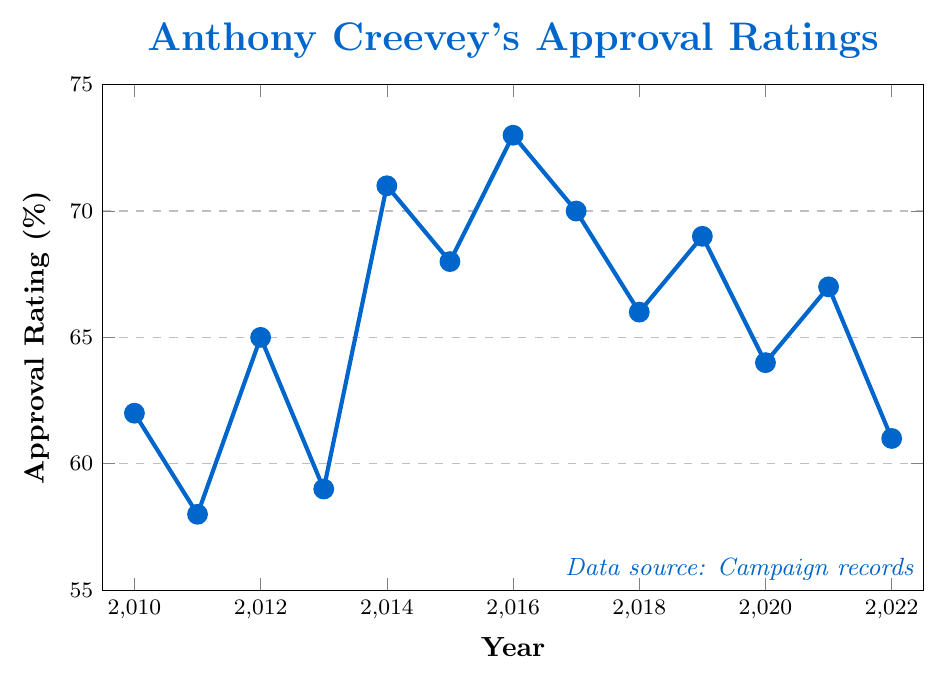What was Anthony Creevey's highest approval rating, and in which year did it occur? Look at the peak point of the line on the figure. The highest approval rating is shown as the tallest marker on the graph. It occurs at 2016 with a value of 73%.
Answer: 73%, 2016 Which year showed the greatest increase in approval rating from the previous year? Identify the year where the line's increase between two adjacent points is the steepest. The greatest increase goes from 2013 at 59% to 2014 at 71%, an increase of 12 percentage points.
Answer: 2014 In how many different years did Anthony Creevey's approval rating stay above 65%? Identify and count the years where the approval rating points are above 65%. These years are 2012 (65%), 2014 (71%), 2015 (68%), 2016 (73%), 2017 (70%), 2019 (69%), and 2021 (67%). There are 7 such years.
Answer: 7 What is the average approval rating for Anthony Creevey from 2010 to 2022? Sum up all the approval ratings between 2010 and 2022 and divide by the number of years. (62 + 58 + 65 + 59 + 71 + 68 + 73 + 70 + 66 + 69 + 64 + 67 + 61) / 13 = 65.31
Answer: 65.31 Compare the approval rating in 2010 with that in 2022. How did it change? Examine the two values for 2010 and 2022. In 2010, it was 62%, and in 2022, it was 61%, showing a decrease of 1 percentage point.
Answer: Decreased by 1 percentage point What was the lowest approval rating and when did it occur? Find the lowest point on the line chart. This occurs at 2011 with the lowest approval rating of 58%.
Answer: 58%, 2011 Identify the year where the approval rating first surpassed 70%. Look for the point where the rating first crosses the 70% line. The first occurrence is in 2014 with a 71% rating.
Answer: 2014 What is the difference in approval ratings between the highest and lowest years? Subtract the lowest approval rating from the highest. The highest is 73% (2016), and the lowest is 58% (2011), so 73 - 58 = 15 percentage points.
Answer: 15 From which year to which year did the approval rating steadily increase without a drop? Look for a continuous upward trend. From 2013 (59%) to 2016 (73%) there is a continuous increase.
Answer: 2013 to 2016 